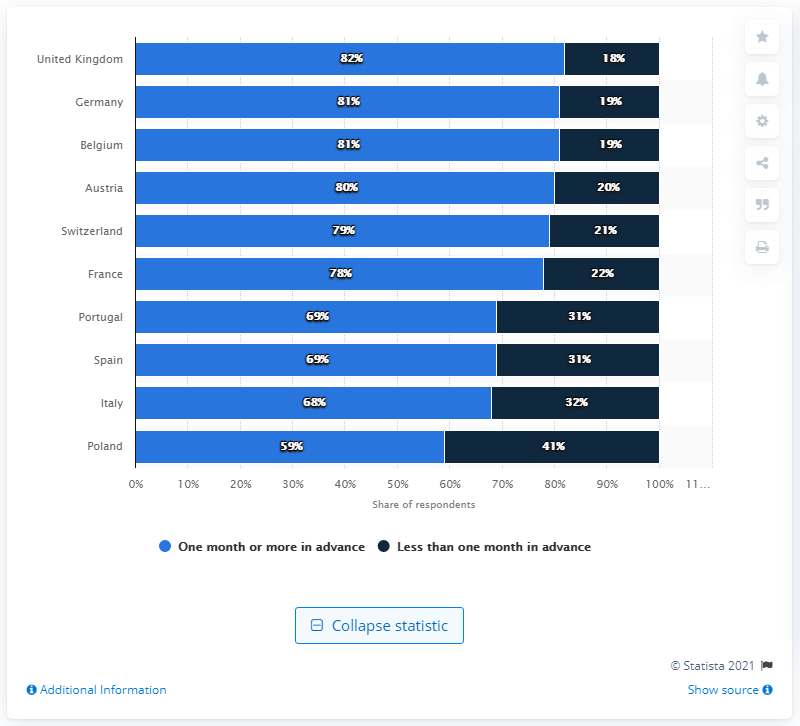Outline some significant characteristics in this image. According to the survey, 81% of German tourists planned to book their summer holiday at least one month in advance. In the UK, 82% of tourists planned to book their summer holiday at least one month in advance. 